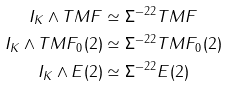<formula> <loc_0><loc_0><loc_500><loc_500>I _ { K } \wedge T M F & \simeq \Sigma ^ { - 2 2 } T M F \\ I _ { K } \wedge T M F _ { 0 } ( 2 ) & \simeq \Sigma ^ { - 2 2 } T M F _ { 0 } ( 2 ) \\ I _ { K } \wedge E ( 2 ) & \simeq \Sigma ^ { - 2 2 } E ( 2 )</formula> 